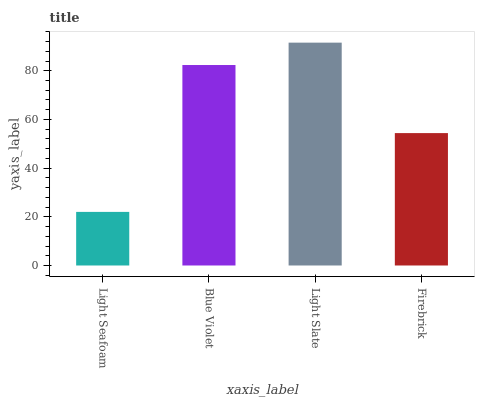Is Light Seafoam the minimum?
Answer yes or no. Yes. Is Light Slate the maximum?
Answer yes or no. Yes. Is Blue Violet the minimum?
Answer yes or no. No. Is Blue Violet the maximum?
Answer yes or no. No. Is Blue Violet greater than Light Seafoam?
Answer yes or no. Yes. Is Light Seafoam less than Blue Violet?
Answer yes or no. Yes. Is Light Seafoam greater than Blue Violet?
Answer yes or no. No. Is Blue Violet less than Light Seafoam?
Answer yes or no. No. Is Blue Violet the high median?
Answer yes or no. Yes. Is Firebrick the low median?
Answer yes or no. Yes. Is Light Seafoam the high median?
Answer yes or no. No. Is Light Slate the low median?
Answer yes or no. No. 